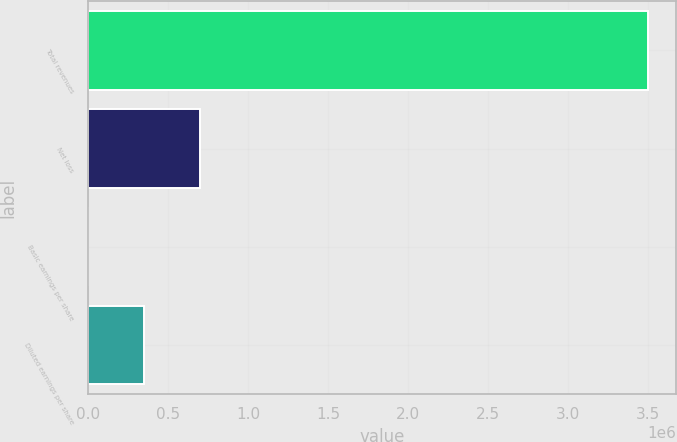Convert chart to OTSL. <chart><loc_0><loc_0><loc_500><loc_500><bar_chart><fcel>Total revenues<fcel>Net loss<fcel>Basic earnings per share<fcel>Diluted earnings per share<nl><fcel>3.49857e+06<fcel>699715<fcel>1.52<fcel>349858<nl></chart> 